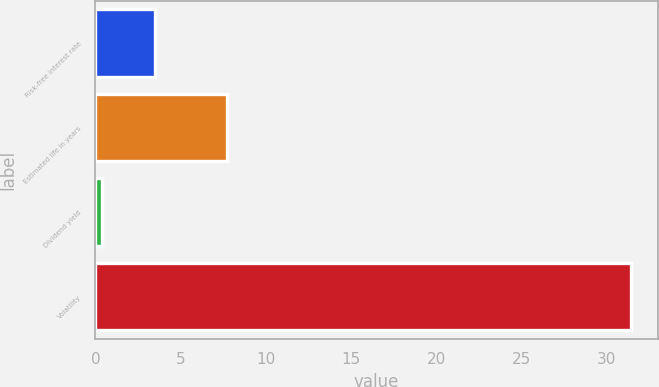Convert chart to OTSL. <chart><loc_0><loc_0><loc_500><loc_500><bar_chart><fcel>Risk-free interest rate<fcel>Estimated life in years<fcel>Dividend yield<fcel>Volatility<nl><fcel>3.48<fcel>7.7<fcel>0.38<fcel>31.4<nl></chart> 